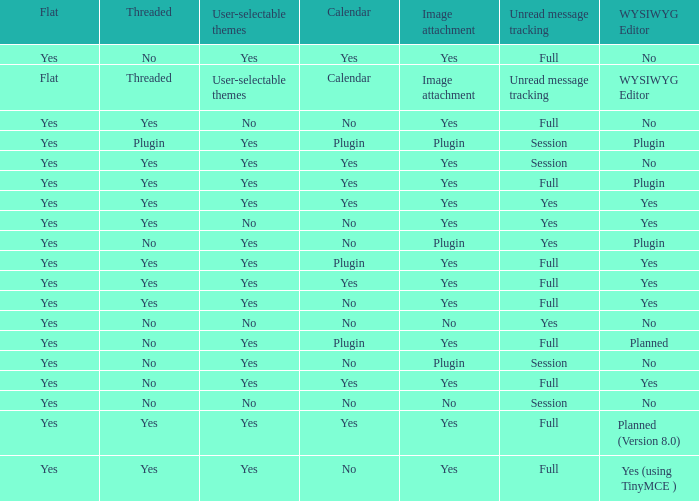Which WYSIWYG Editor has an Image attachment of yes, and a Calendar of plugin? Yes, Planned. 